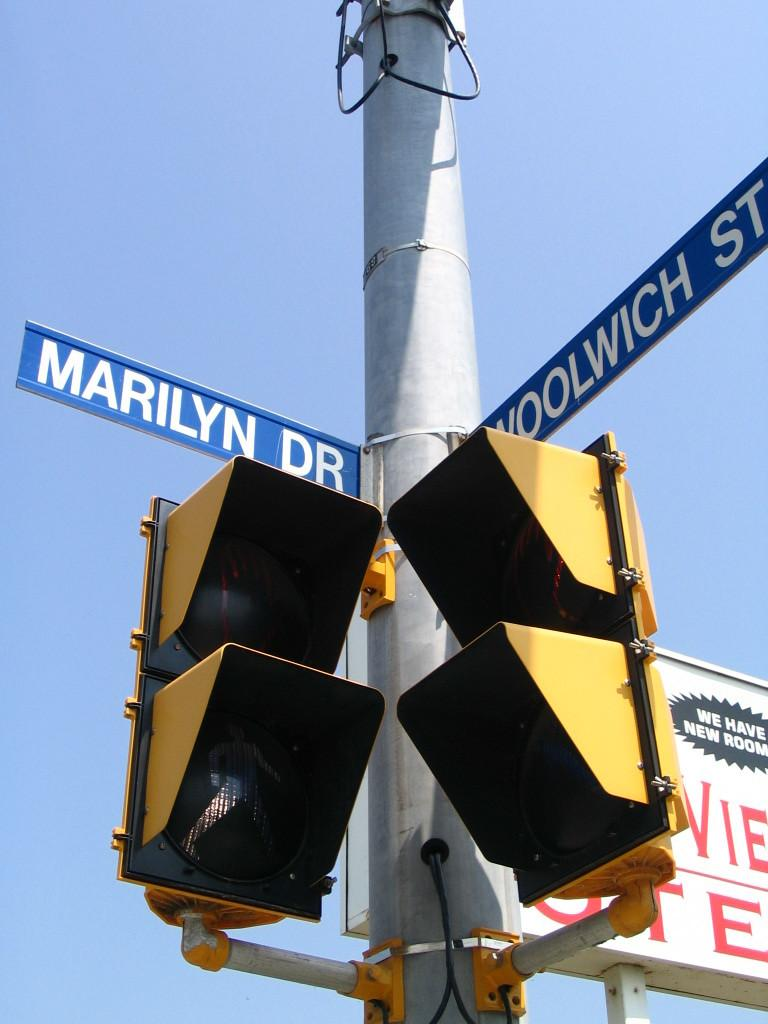<image>
Relay a brief, clear account of the picture shown. Blue  street signs for  intersection of Marilyn and Woowich streets above a street signal 